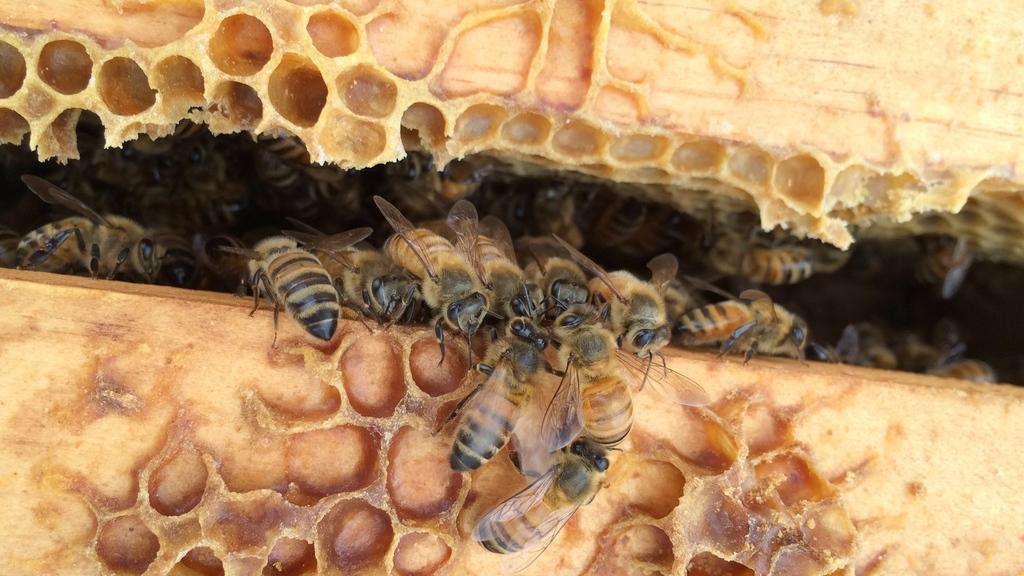How would you summarize this image in a sentence or two? In this image we can see few insects looks like honey bees in the bee hive. 